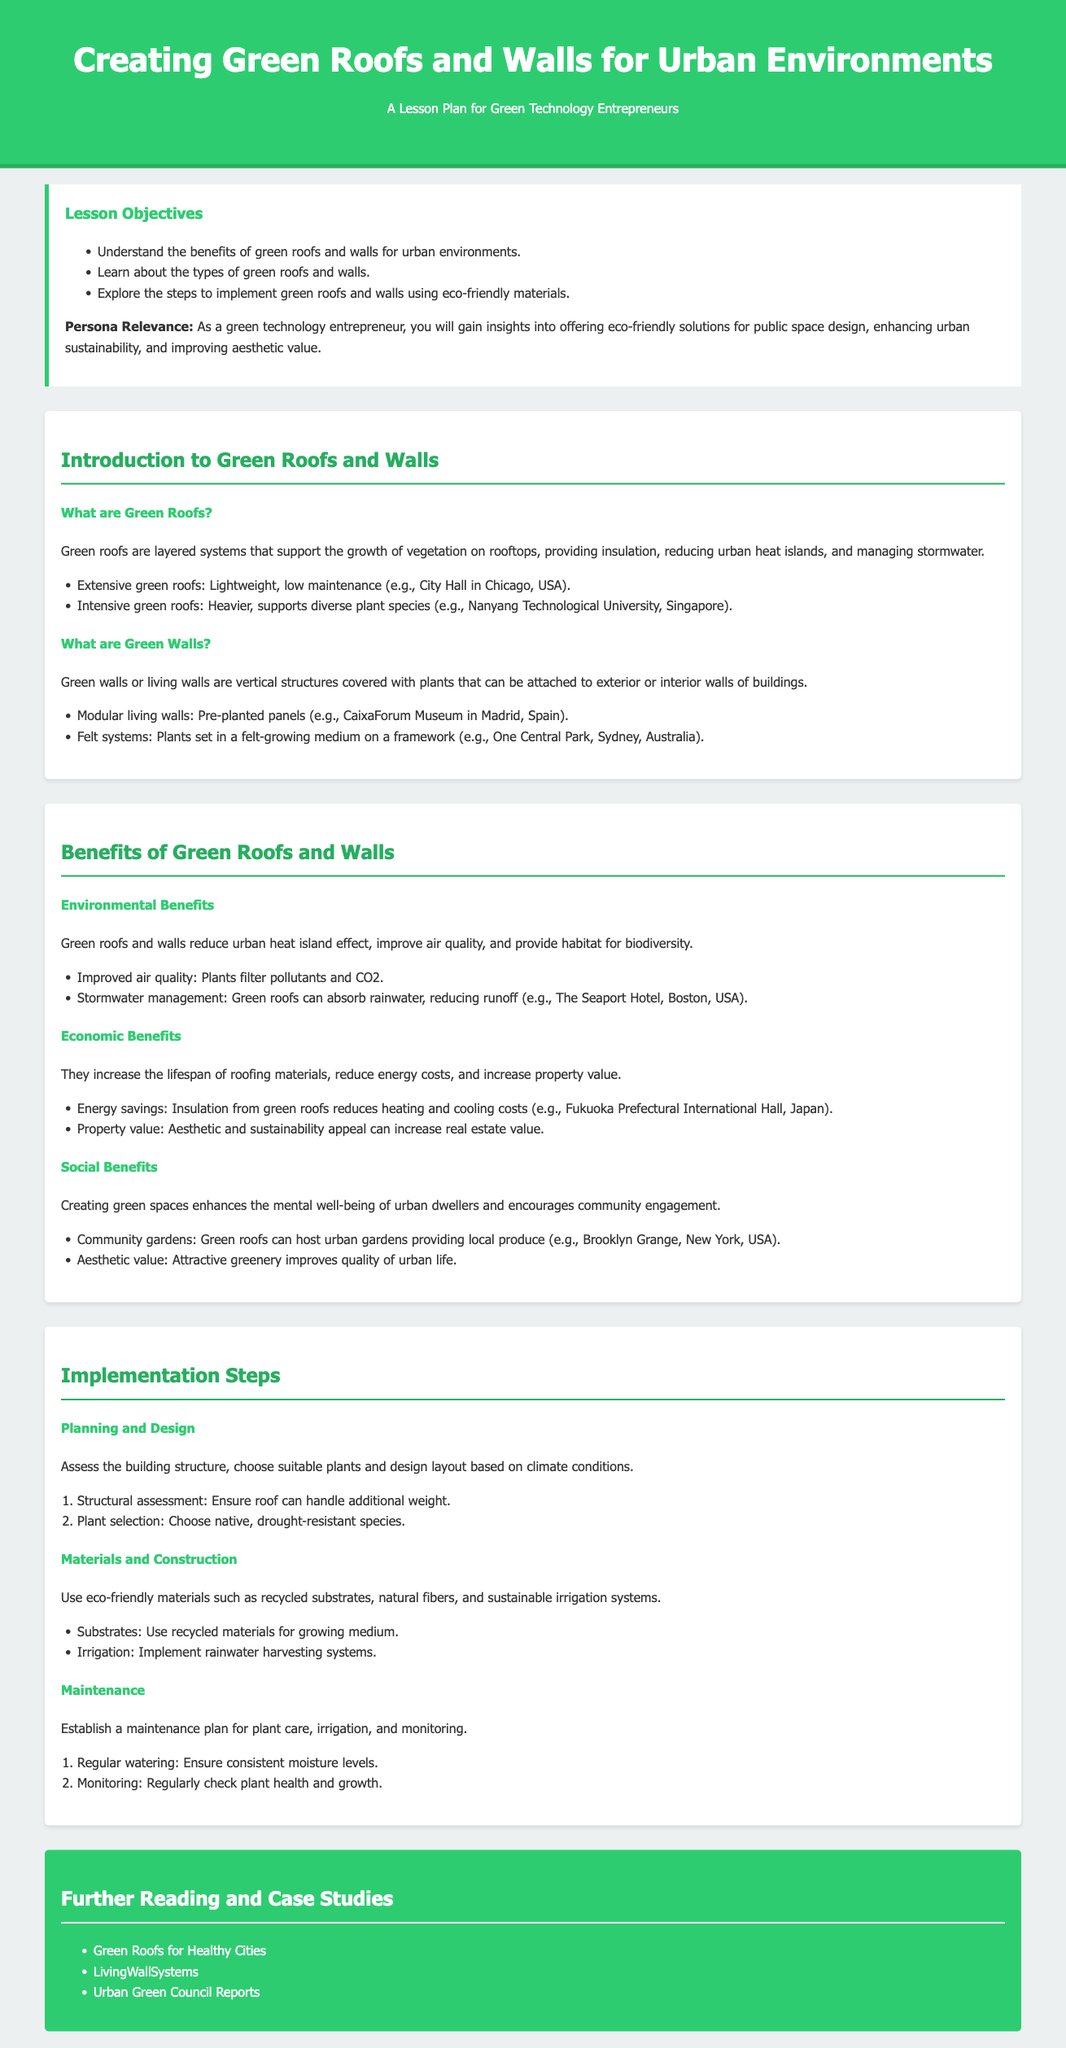what are two types of green roofs? The document lists extensive and intensive green roofs as types of green roofs.
Answer: extensive and intensive what is the primary color used in the header? The primary color used in the header section of the document is specified in the CSS styles.
Answer: #2ecc71 which type of green wall uses pre-planted panels? The document mentions modular living walls as the type that uses pre-planted panels.
Answer: modular living walls name one economic benefit of green roofs and walls. The document states that they increase the lifespan of roofing materials among other economic benefits.
Answer: increase lifespan of roofing materials what is an example of a community garden on a green roof? The document provides Brooklyn Grange, New York, USA as an example of a community garden on a green roof.
Answer: Brooklyn Grange how many steps are mentioned for maintenance? The document outlines two essential steps for maintenance of green roofs and walls.
Answer: 2 what is the first step in planning and design? The first step in planning and design is a structural assessment.
Answer: structural assessment which city is the Seaport Hotel located in? The document states that the Seaport Hotel is located in Boston, USA.
Answer: Boston what do green roofs and walls help reduce according to environmental benefits? The document highlights that green roofs and walls reduce the urban heat island effect as an environmental benefit.
Answer: urban heat island effect 